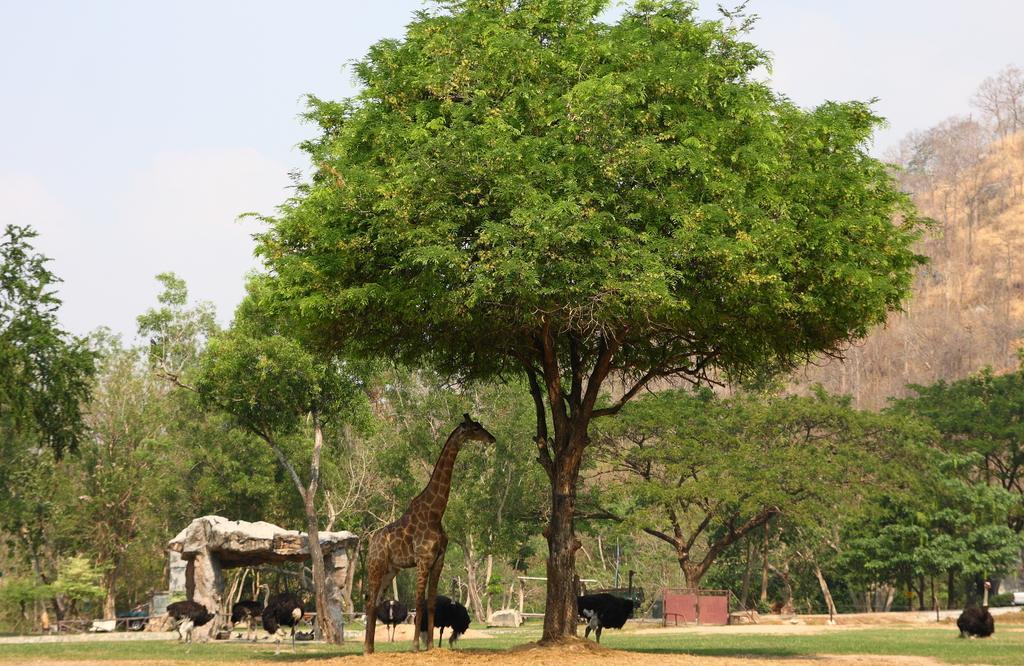Could you give a brief overview of what you see in this image? In this image there is one giraffe and some birds are standing on the bottom of this image and there are some trees in the background. There is a sky on the top of this image , and there is a shelter on the left side of this image. 